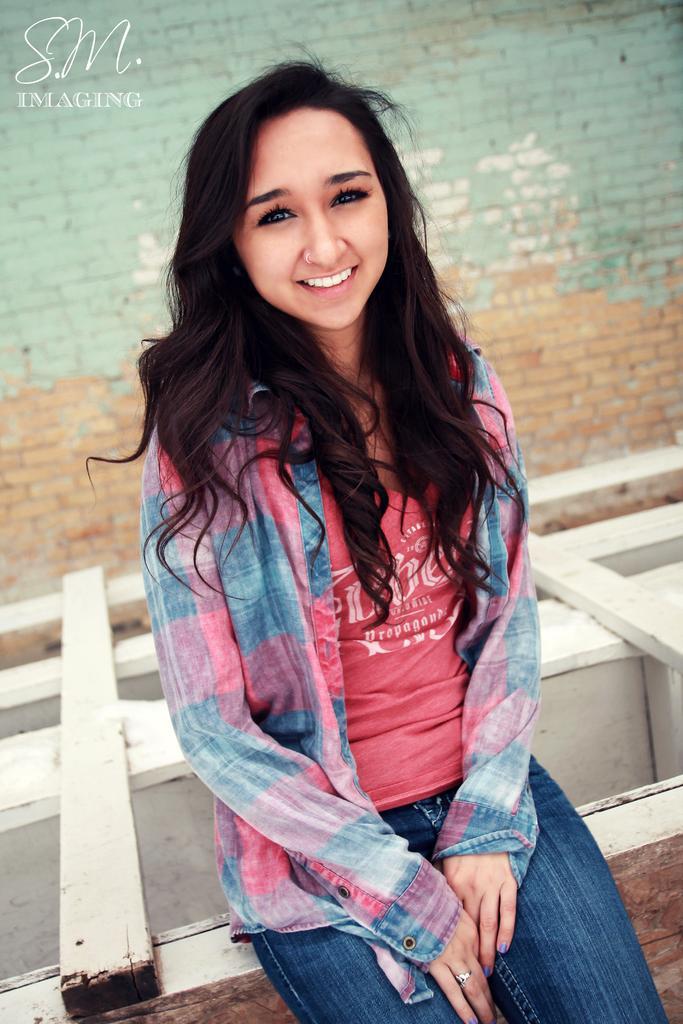Please provide a concise description of this image. This girl is smiling and looking forward. Background there is a brick wall. This is wooden surface. Left side corner of the image there is a watermark. 